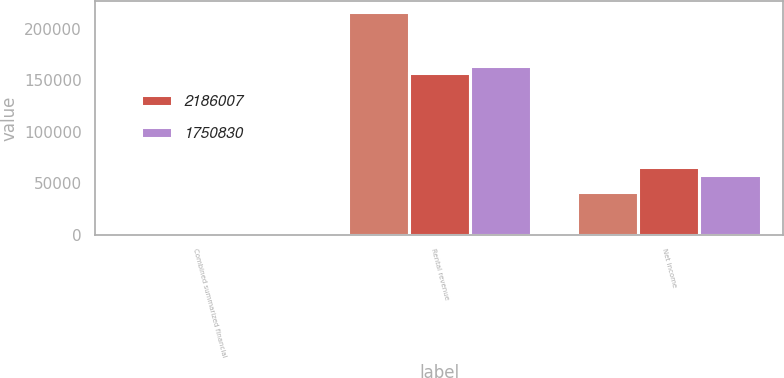Convert chart to OTSL. <chart><loc_0><loc_0><loc_500><loc_500><stacked_bar_chart><ecel><fcel>Combined summarized financial<fcel>Rental revenue<fcel>Net income<nl><fcel>nan<fcel>2007<fcel>215855<fcel>41725<nl><fcel>2.18601e+06<fcel>2006<fcel>157186<fcel>65985<nl><fcel>1.75083e+06<fcel>2005<fcel>163447<fcel>57561<nl></chart> 